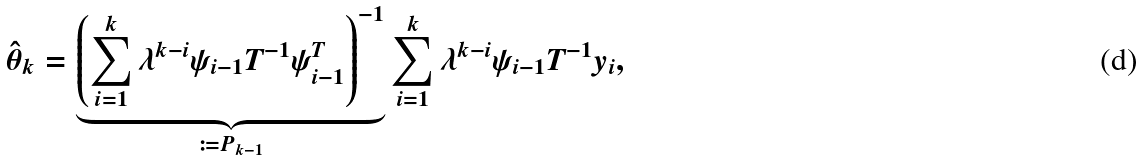Convert formula to latex. <formula><loc_0><loc_0><loc_500><loc_500>\hat { \theta } _ { k } = \underbrace { \left ( \sum _ { i = 1 } ^ { k } \lambda ^ { k - i } \psi _ { i - 1 } T ^ { - 1 } \psi _ { i - 1 } ^ { T } \right ) ^ { - 1 } } _ { \coloneqq P _ { k - 1 } } \sum _ { i = 1 } ^ { k } \lambda ^ { k - i } \psi _ { i - 1 } T ^ { - 1 } y _ { i } ,</formula> 